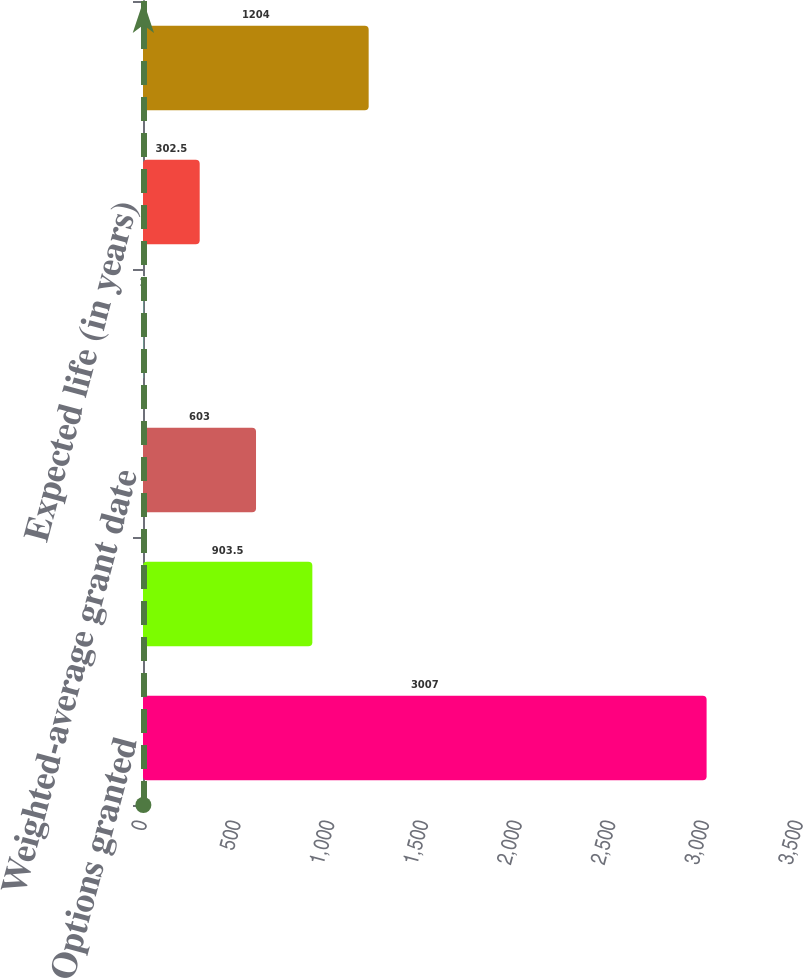<chart> <loc_0><loc_0><loc_500><loc_500><bar_chart><fcel>Options granted<fcel>Weighted-average exercise<fcel>Weighted-average grant date<fcel>Risk-free interest rates<fcel>Expected life (in years)<fcel>Expected volatility<nl><fcel>3007<fcel>903.5<fcel>603<fcel>2<fcel>302.5<fcel>1204<nl></chart> 